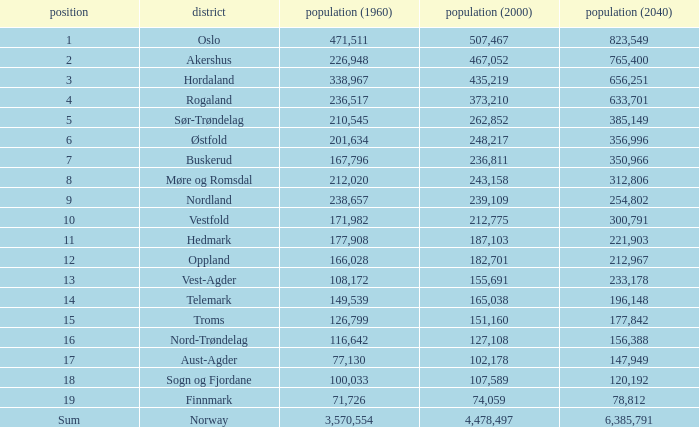What was Oslo's population in 1960, with a population of 507,467 in 2000? None. 